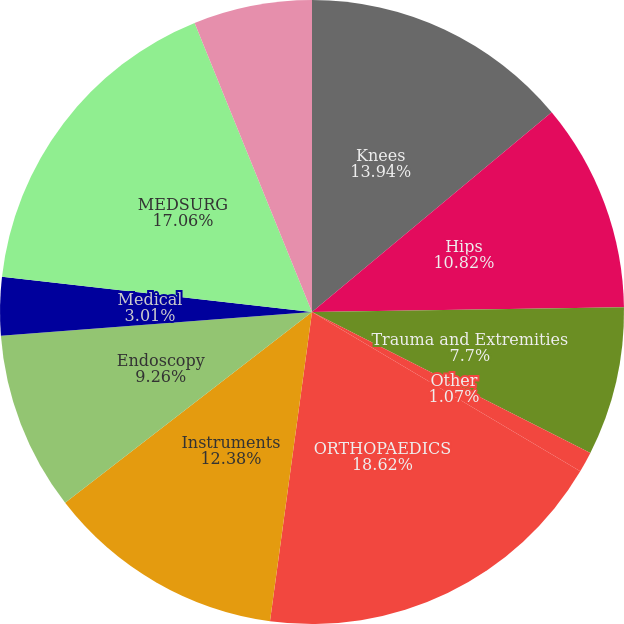Convert chart to OTSL. <chart><loc_0><loc_0><loc_500><loc_500><pie_chart><fcel>Knees<fcel>Hips<fcel>Trauma and Extremities<fcel>Other<fcel>ORTHOPAEDICS<fcel>Instruments<fcel>Endoscopy<fcel>Medical<fcel>MEDSURG<fcel>Neurotechnology<nl><fcel>13.94%<fcel>10.82%<fcel>7.7%<fcel>1.07%<fcel>18.62%<fcel>12.38%<fcel>9.26%<fcel>3.01%<fcel>17.06%<fcel>6.14%<nl></chart> 